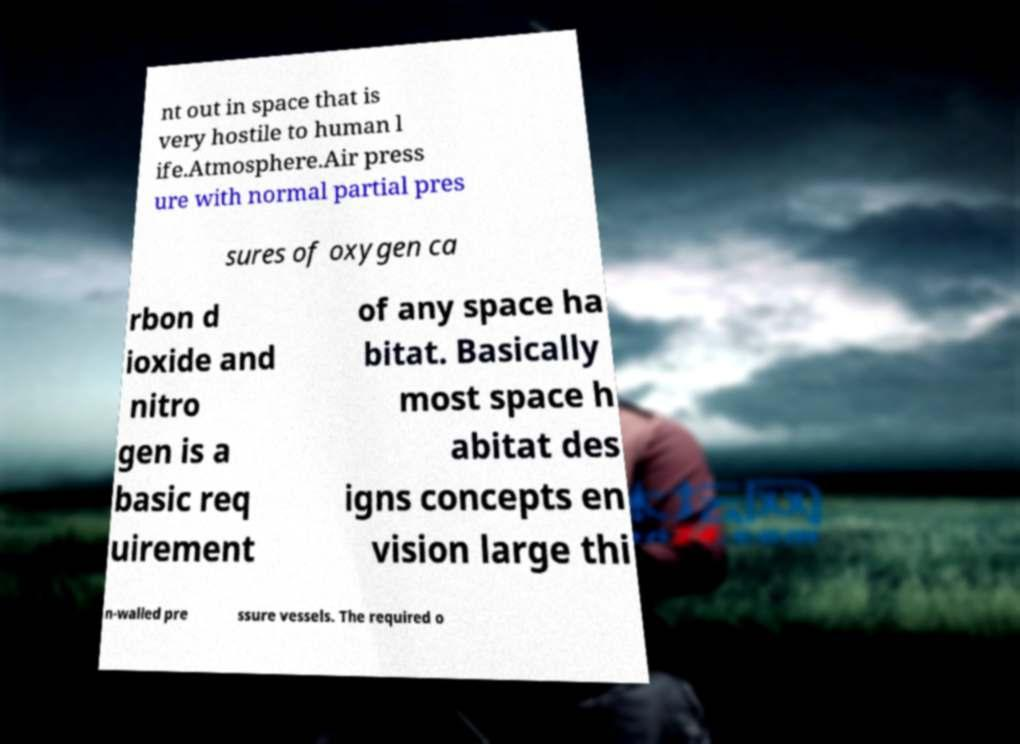Can you read and provide the text displayed in the image?This photo seems to have some interesting text. Can you extract and type it out for me? nt out in space that is very hostile to human l ife.Atmosphere.Air press ure with normal partial pres sures of oxygen ca rbon d ioxide and nitro gen is a basic req uirement of any space ha bitat. Basically most space h abitat des igns concepts en vision large thi n-walled pre ssure vessels. The required o 